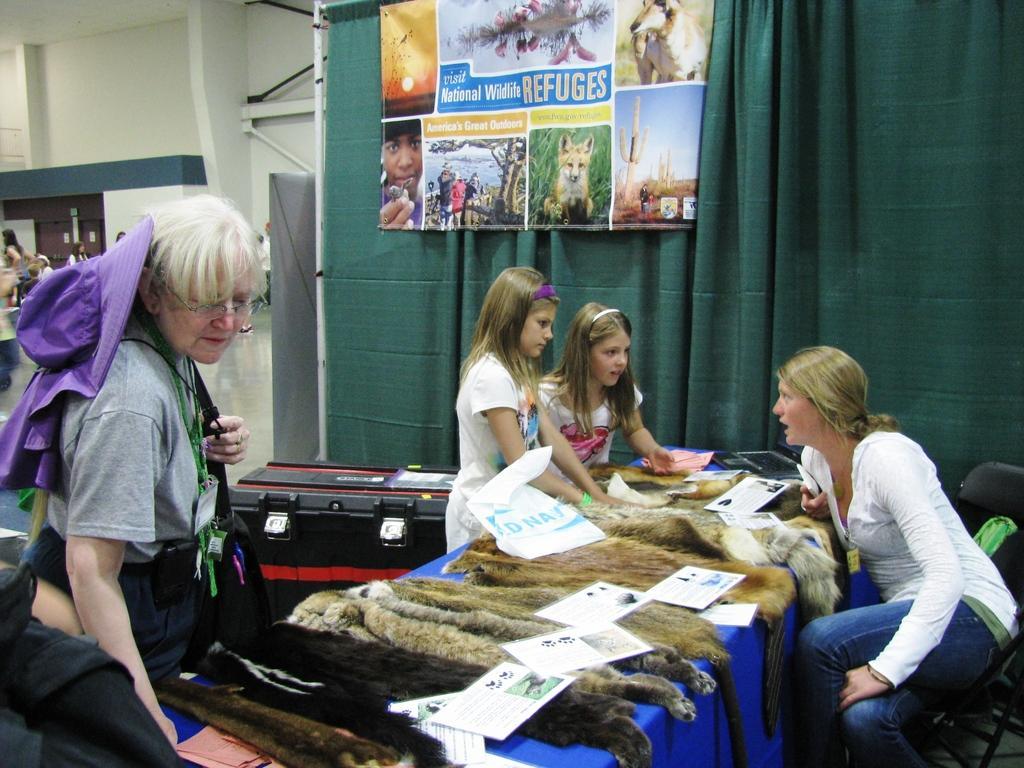In one or two sentences, can you explain what this image depicts? In this image there are a few people sitting and standing, in between them there is a table, on the table there is like a skin of a few animals and some papers with some text and images on it, beside the table there is a box, behind the box there is a curtain and a banner with some images and text on it. On the left side of the image there are a few people. In the background there is a wall. 